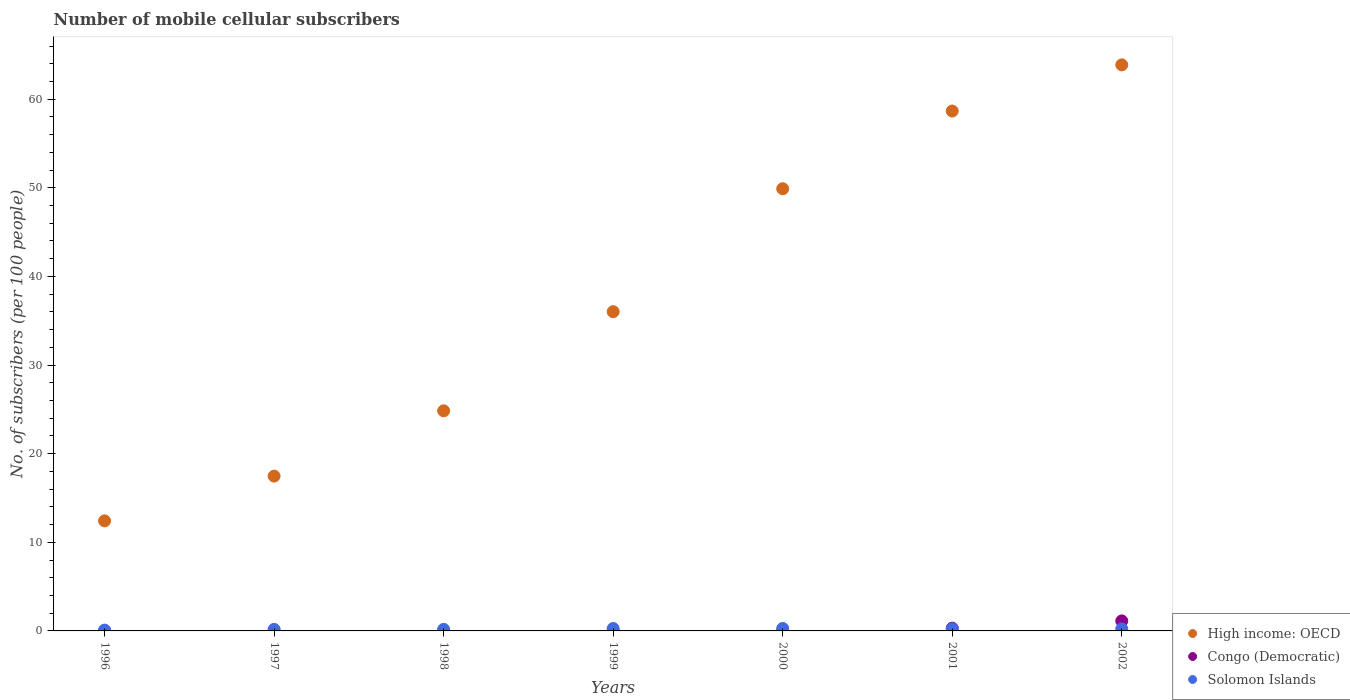How many different coloured dotlines are there?
Your answer should be very brief. 3. Is the number of dotlines equal to the number of legend labels?
Give a very brief answer. Yes. What is the number of mobile cellular subscribers in Congo (Democratic) in 2002?
Make the answer very short. 1.13. Across all years, what is the maximum number of mobile cellular subscribers in High income: OECD?
Ensure brevity in your answer.  63.87. Across all years, what is the minimum number of mobile cellular subscribers in Solomon Islands?
Your answer should be very brief. 0.09. In which year was the number of mobile cellular subscribers in Solomon Islands maximum?
Ensure brevity in your answer.  2000. What is the total number of mobile cellular subscribers in High income: OECD in the graph?
Give a very brief answer. 263.18. What is the difference between the number of mobile cellular subscribers in Solomon Islands in 1999 and that in 2002?
Provide a short and direct response. 0.04. What is the difference between the number of mobile cellular subscribers in Solomon Islands in 2000 and the number of mobile cellular subscribers in High income: OECD in 1996?
Give a very brief answer. -12.14. What is the average number of mobile cellular subscribers in High income: OECD per year?
Your answer should be very brief. 37.6. In the year 2000, what is the difference between the number of mobile cellular subscribers in High income: OECD and number of mobile cellular subscribers in Solomon Islands?
Offer a terse response. 49.62. In how many years, is the number of mobile cellular subscribers in Solomon Islands greater than 28?
Your answer should be very brief. 0. What is the ratio of the number of mobile cellular subscribers in Congo (Democratic) in 1999 to that in 2002?
Give a very brief answer. 0.02. Is the difference between the number of mobile cellular subscribers in High income: OECD in 1996 and 2001 greater than the difference between the number of mobile cellular subscribers in Solomon Islands in 1996 and 2001?
Offer a terse response. No. What is the difference between the highest and the second highest number of mobile cellular subscribers in Congo (Democratic)?
Offer a terse response. 0.82. What is the difference between the highest and the lowest number of mobile cellular subscribers in Solomon Islands?
Your answer should be very brief. 0.19. In how many years, is the number of mobile cellular subscribers in Solomon Islands greater than the average number of mobile cellular subscribers in Solomon Islands taken over all years?
Your response must be concise. 4. Does the number of mobile cellular subscribers in Solomon Islands monotonically increase over the years?
Give a very brief answer. No. Is the number of mobile cellular subscribers in High income: OECD strictly greater than the number of mobile cellular subscribers in Solomon Islands over the years?
Keep it short and to the point. Yes. Is the number of mobile cellular subscribers in Congo (Democratic) strictly less than the number of mobile cellular subscribers in Solomon Islands over the years?
Ensure brevity in your answer.  No. How many years are there in the graph?
Your answer should be very brief. 7. What is the difference between two consecutive major ticks on the Y-axis?
Your answer should be compact. 10. Does the graph contain any zero values?
Make the answer very short. No. Where does the legend appear in the graph?
Give a very brief answer. Bottom right. What is the title of the graph?
Offer a very short reply. Number of mobile cellular subscribers. What is the label or title of the Y-axis?
Offer a very short reply. No. of subscribers (per 100 people). What is the No. of subscribers (per 100 people) in High income: OECD in 1996?
Provide a succinct answer. 12.42. What is the No. of subscribers (per 100 people) of Congo (Democratic) in 1996?
Your answer should be very brief. 0.02. What is the No. of subscribers (per 100 people) of Solomon Islands in 1996?
Keep it short and to the point. 0.09. What is the No. of subscribers (per 100 people) of High income: OECD in 1997?
Your answer should be compact. 17.47. What is the No. of subscribers (per 100 people) of Congo (Democratic) in 1997?
Your response must be concise. 0.02. What is the No. of subscribers (per 100 people) in Solomon Islands in 1997?
Your answer should be very brief. 0.17. What is the No. of subscribers (per 100 people) in High income: OECD in 1998?
Ensure brevity in your answer.  24.84. What is the No. of subscribers (per 100 people) in Congo (Democratic) in 1998?
Your answer should be compact. 0.02. What is the No. of subscribers (per 100 people) in Solomon Islands in 1998?
Ensure brevity in your answer.  0.18. What is the No. of subscribers (per 100 people) of High income: OECD in 1999?
Ensure brevity in your answer.  36.03. What is the No. of subscribers (per 100 people) of Congo (Democratic) in 1999?
Your answer should be compact. 0.03. What is the No. of subscribers (per 100 people) of Solomon Islands in 1999?
Make the answer very short. 0.27. What is the No. of subscribers (per 100 people) in High income: OECD in 2000?
Keep it short and to the point. 49.9. What is the No. of subscribers (per 100 people) of Congo (Democratic) in 2000?
Provide a succinct answer. 0.03. What is the No. of subscribers (per 100 people) of Solomon Islands in 2000?
Your response must be concise. 0.28. What is the No. of subscribers (per 100 people) of High income: OECD in 2001?
Your response must be concise. 58.66. What is the No. of subscribers (per 100 people) of Congo (Democratic) in 2001?
Your answer should be compact. 0.31. What is the No. of subscribers (per 100 people) in Solomon Islands in 2001?
Your answer should be very brief. 0.23. What is the No. of subscribers (per 100 people) of High income: OECD in 2002?
Offer a terse response. 63.87. What is the No. of subscribers (per 100 people) in Congo (Democratic) in 2002?
Provide a short and direct response. 1.13. What is the No. of subscribers (per 100 people) of Solomon Islands in 2002?
Keep it short and to the point. 0.23. Across all years, what is the maximum No. of subscribers (per 100 people) of High income: OECD?
Your answer should be very brief. 63.87. Across all years, what is the maximum No. of subscribers (per 100 people) of Congo (Democratic)?
Offer a terse response. 1.13. Across all years, what is the maximum No. of subscribers (per 100 people) in Solomon Islands?
Provide a succinct answer. 0.28. Across all years, what is the minimum No. of subscribers (per 100 people) in High income: OECD?
Provide a short and direct response. 12.42. Across all years, what is the minimum No. of subscribers (per 100 people) of Congo (Democratic)?
Keep it short and to the point. 0.02. Across all years, what is the minimum No. of subscribers (per 100 people) of Solomon Islands?
Your answer should be compact. 0.09. What is the total No. of subscribers (per 100 people) of High income: OECD in the graph?
Your response must be concise. 263.18. What is the total No. of subscribers (per 100 people) in Congo (Democratic) in the graph?
Your answer should be compact. 1.56. What is the total No. of subscribers (per 100 people) in Solomon Islands in the graph?
Give a very brief answer. 1.45. What is the difference between the No. of subscribers (per 100 people) of High income: OECD in 1996 and that in 1997?
Provide a short and direct response. -5.05. What is the difference between the No. of subscribers (per 100 people) in Congo (Democratic) in 1996 and that in 1997?
Your answer should be very brief. -0. What is the difference between the No. of subscribers (per 100 people) of Solomon Islands in 1996 and that in 1997?
Give a very brief answer. -0.08. What is the difference between the No. of subscribers (per 100 people) of High income: OECD in 1996 and that in 1998?
Keep it short and to the point. -12.42. What is the difference between the No. of subscribers (per 100 people) of Congo (Democratic) in 1996 and that in 1998?
Offer a very short reply. -0.01. What is the difference between the No. of subscribers (per 100 people) of Solomon Islands in 1996 and that in 1998?
Offer a terse response. -0.09. What is the difference between the No. of subscribers (per 100 people) of High income: OECD in 1996 and that in 1999?
Offer a very short reply. -23.6. What is the difference between the No. of subscribers (per 100 people) of Congo (Democratic) in 1996 and that in 1999?
Give a very brief answer. -0.01. What is the difference between the No. of subscribers (per 100 people) of Solomon Islands in 1996 and that in 1999?
Your answer should be very brief. -0.18. What is the difference between the No. of subscribers (per 100 people) in High income: OECD in 1996 and that in 2000?
Keep it short and to the point. -37.47. What is the difference between the No. of subscribers (per 100 people) of Congo (Democratic) in 1996 and that in 2000?
Provide a succinct answer. -0.02. What is the difference between the No. of subscribers (per 100 people) in Solomon Islands in 1996 and that in 2000?
Provide a short and direct response. -0.19. What is the difference between the No. of subscribers (per 100 people) of High income: OECD in 1996 and that in 2001?
Offer a terse response. -46.24. What is the difference between the No. of subscribers (per 100 people) in Congo (Democratic) in 1996 and that in 2001?
Your answer should be very brief. -0.29. What is the difference between the No. of subscribers (per 100 people) in Solomon Islands in 1996 and that in 2001?
Give a very brief answer. -0.14. What is the difference between the No. of subscribers (per 100 people) in High income: OECD in 1996 and that in 2002?
Offer a very short reply. -51.45. What is the difference between the No. of subscribers (per 100 people) in Congo (Democratic) in 1996 and that in 2002?
Provide a succinct answer. -1.11. What is the difference between the No. of subscribers (per 100 people) in Solomon Islands in 1996 and that in 2002?
Offer a terse response. -0.14. What is the difference between the No. of subscribers (per 100 people) in High income: OECD in 1997 and that in 1998?
Keep it short and to the point. -7.37. What is the difference between the No. of subscribers (per 100 people) in Congo (Democratic) in 1997 and that in 1998?
Keep it short and to the point. -0. What is the difference between the No. of subscribers (per 100 people) of Solomon Islands in 1997 and that in 1998?
Provide a short and direct response. -0.01. What is the difference between the No. of subscribers (per 100 people) in High income: OECD in 1997 and that in 1999?
Keep it short and to the point. -18.56. What is the difference between the No. of subscribers (per 100 people) in Congo (Democratic) in 1997 and that in 1999?
Your answer should be compact. -0.01. What is the difference between the No. of subscribers (per 100 people) in Solomon Islands in 1997 and that in 1999?
Offer a very short reply. -0.1. What is the difference between the No. of subscribers (per 100 people) in High income: OECD in 1997 and that in 2000?
Provide a succinct answer. -32.43. What is the difference between the No. of subscribers (per 100 people) in Congo (Democratic) in 1997 and that in 2000?
Keep it short and to the point. -0.01. What is the difference between the No. of subscribers (per 100 people) of Solomon Islands in 1997 and that in 2000?
Give a very brief answer. -0.11. What is the difference between the No. of subscribers (per 100 people) of High income: OECD in 1997 and that in 2001?
Offer a very short reply. -41.19. What is the difference between the No. of subscribers (per 100 people) of Congo (Democratic) in 1997 and that in 2001?
Provide a succinct answer. -0.29. What is the difference between the No. of subscribers (per 100 people) of Solomon Islands in 1997 and that in 2001?
Provide a short and direct response. -0.06. What is the difference between the No. of subscribers (per 100 people) of High income: OECD in 1997 and that in 2002?
Offer a very short reply. -46.4. What is the difference between the No. of subscribers (per 100 people) of Congo (Democratic) in 1997 and that in 2002?
Make the answer very short. -1.11. What is the difference between the No. of subscribers (per 100 people) of Solomon Islands in 1997 and that in 2002?
Provide a short and direct response. -0.06. What is the difference between the No. of subscribers (per 100 people) of High income: OECD in 1998 and that in 1999?
Offer a very short reply. -11.19. What is the difference between the No. of subscribers (per 100 people) of Congo (Democratic) in 1998 and that in 1999?
Your answer should be very brief. -0. What is the difference between the No. of subscribers (per 100 people) of Solomon Islands in 1998 and that in 1999?
Your answer should be very brief. -0.09. What is the difference between the No. of subscribers (per 100 people) in High income: OECD in 1998 and that in 2000?
Keep it short and to the point. -25.06. What is the difference between the No. of subscribers (per 100 people) of Congo (Democratic) in 1998 and that in 2000?
Make the answer very short. -0.01. What is the difference between the No. of subscribers (per 100 people) of Solomon Islands in 1998 and that in 2000?
Your response must be concise. -0.1. What is the difference between the No. of subscribers (per 100 people) of High income: OECD in 1998 and that in 2001?
Provide a short and direct response. -33.83. What is the difference between the No. of subscribers (per 100 people) in Congo (Democratic) in 1998 and that in 2001?
Provide a succinct answer. -0.29. What is the difference between the No. of subscribers (per 100 people) of Solomon Islands in 1998 and that in 2001?
Ensure brevity in your answer.  -0.05. What is the difference between the No. of subscribers (per 100 people) of High income: OECD in 1998 and that in 2002?
Your answer should be compact. -39.04. What is the difference between the No. of subscribers (per 100 people) of Congo (Democratic) in 1998 and that in 2002?
Make the answer very short. -1.11. What is the difference between the No. of subscribers (per 100 people) of Solomon Islands in 1998 and that in 2002?
Your answer should be compact. -0.05. What is the difference between the No. of subscribers (per 100 people) in High income: OECD in 1999 and that in 2000?
Your answer should be very brief. -13.87. What is the difference between the No. of subscribers (per 100 people) in Congo (Democratic) in 1999 and that in 2000?
Provide a short and direct response. -0.01. What is the difference between the No. of subscribers (per 100 people) in Solomon Islands in 1999 and that in 2000?
Your answer should be very brief. -0.01. What is the difference between the No. of subscribers (per 100 people) in High income: OECD in 1999 and that in 2001?
Provide a succinct answer. -22.64. What is the difference between the No. of subscribers (per 100 people) in Congo (Democratic) in 1999 and that in 2001?
Offer a very short reply. -0.29. What is the difference between the No. of subscribers (per 100 people) of Solomon Islands in 1999 and that in 2001?
Ensure brevity in your answer.  0.04. What is the difference between the No. of subscribers (per 100 people) of High income: OECD in 1999 and that in 2002?
Offer a terse response. -27.85. What is the difference between the No. of subscribers (per 100 people) of Congo (Democratic) in 1999 and that in 2002?
Ensure brevity in your answer.  -1.1. What is the difference between the No. of subscribers (per 100 people) in Solomon Islands in 1999 and that in 2002?
Your answer should be very brief. 0.04. What is the difference between the No. of subscribers (per 100 people) of High income: OECD in 2000 and that in 2001?
Provide a short and direct response. -8.77. What is the difference between the No. of subscribers (per 100 people) in Congo (Democratic) in 2000 and that in 2001?
Make the answer very short. -0.28. What is the difference between the No. of subscribers (per 100 people) in Solomon Islands in 2000 and that in 2001?
Offer a very short reply. 0.05. What is the difference between the No. of subscribers (per 100 people) of High income: OECD in 2000 and that in 2002?
Your response must be concise. -13.98. What is the difference between the No. of subscribers (per 100 people) of Congo (Democratic) in 2000 and that in 2002?
Your answer should be compact. -1.1. What is the difference between the No. of subscribers (per 100 people) of Solomon Islands in 2000 and that in 2002?
Your response must be concise. 0.05. What is the difference between the No. of subscribers (per 100 people) in High income: OECD in 2001 and that in 2002?
Give a very brief answer. -5.21. What is the difference between the No. of subscribers (per 100 people) of Congo (Democratic) in 2001 and that in 2002?
Your answer should be very brief. -0.82. What is the difference between the No. of subscribers (per 100 people) in Solomon Islands in 2001 and that in 2002?
Your answer should be very brief. -0. What is the difference between the No. of subscribers (per 100 people) in High income: OECD in 1996 and the No. of subscribers (per 100 people) in Congo (Democratic) in 1997?
Make the answer very short. 12.4. What is the difference between the No. of subscribers (per 100 people) of High income: OECD in 1996 and the No. of subscribers (per 100 people) of Solomon Islands in 1997?
Your response must be concise. 12.25. What is the difference between the No. of subscribers (per 100 people) in Congo (Democratic) in 1996 and the No. of subscribers (per 100 people) in Solomon Islands in 1997?
Ensure brevity in your answer.  -0.16. What is the difference between the No. of subscribers (per 100 people) in High income: OECD in 1996 and the No. of subscribers (per 100 people) in Congo (Democratic) in 1998?
Make the answer very short. 12.4. What is the difference between the No. of subscribers (per 100 people) in High income: OECD in 1996 and the No. of subscribers (per 100 people) in Solomon Islands in 1998?
Make the answer very short. 12.24. What is the difference between the No. of subscribers (per 100 people) in Congo (Democratic) in 1996 and the No. of subscribers (per 100 people) in Solomon Islands in 1998?
Your answer should be compact. -0.16. What is the difference between the No. of subscribers (per 100 people) in High income: OECD in 1996 and the No. of subscribers (per 100 people) in Congo (Democratic) in 1999?
Offer a very short reply. 12.4. What is the difference between the No. of subscribers (per 100 people) in High income: OECD in 1996 and the No. of subscribers (per 100 people) in Solomon Islands in 1999?
Provide a short and direct response. 12.15. What is the difference between the No. of subscribers (per 100 people) in Congo (Democratic) in 1996 and the No. of subscribers (per 100 people) in Solomon Islands in 1999?
Your response must be concise. -0.26. What is the difference between the No. of subscribers (per 100 people) of High income: OECD in 1996 and the No. of subscribers (per 100 people) of Congo (Democratic) in 2000?
Your response must be concise. 12.39. What is the difference between the No. of subscribers (per 100 people) in High income: OECD in 1996 and the No. of subscribers (per 100 people) in Solomon Islands in 2000?
Offer a very short reply. 12.14. What is the difference between the No. of subscribers (per 100 people) in Congo (Democratic) in 1996 and the No. of subscribers (per 100 people) in Solomon Islands in 2000?
Your response must be concise. -0.26. What is the difference between the No. of subscribers (per 100 people) of High income: OECD in 1996 and the No. of subscribers (per 100 people) of Congo (Democratic) in 2001?
Your answer should be compact. 12.11. What is the difference between the No. of subscribers (per 100 people) of High income: OECD in 1996 and the No. of subscribers (per 100 people) of Solomon Islands in 2001?
Keep it short and to the point. 12.19. What is the difference between the No. of subscribers (per 100 people) of Congo (Democratic) in 1996 and the No. of subscribers (per 100 people) of Solomon Islands in 2001?
Offer a terse response. -0.21. What is the difference between the No. of subscribers (per 100 people) of High income: OECD in 1996 and the No. of subscribers (per 100 people) of Congo (Democratic) in 2002?
Your answer should be very brief. 11.29. What is the difference between the No. of subscribers (per 100 people) of High income: OECD in 1996 and the No. of subscribers (per 100 people) of Solomon Islands in 2002?
Give a very brief answer. 12.19. What is the difference between the No. of subscribers (per 100 people) in Congo (Democratic) in 1996 and the No. of subscribers (per 100 people) in Solomon Islands in 2002?
Make the answer very short. -0.21. What is the difference between the No. of subscribers (per 100 people) in High income: OECD in 1997 and the No. of subscribers (per 100 people) in Congo (Democratic) in 1998?
Your answer should be very brief. 17.45. What is the difference between the No. of subscribers (per 100 people) in High income: OECD in 1997 and the No. of subscribers (per 100 people) in Solomon Islands in 1998?
Provide a succinct answer. 17.29. What is the difference between the No. of subscribers (per 100 people) in Congo (Democratic) in 1997 and the No. of subscribers (per 100 people) in Solomon Islands in 1998?
Your answer should be very brief. -0.16. What is the difference between the No. of subscribers (per 100 people) of High income: OECD in 1997 and the No. of subscribers (per 100 people) of Congo (Democratic) in 1999?
Offer a very short reply. 17.44. What is the difference between the No. of subscribers (per 100 people) of High income: OECD in 1997 and the No. of subscribers (per 100 people) of Solomon Islands in 1999?
Make the answer very short. 17.2. What is the difference between the No. of subscribers (per 100 people) of Congo (Democratic) in 1997 and the No. of subscribers (per 100 people) of Solomon Islands in 1999?
Keep it short and to the point. -0.25. What is the difference between the No. of subscribers (per 100 people) of High income: OECD in 1997 and the No. of subscribers (per 100 people) of Congo (Democratic) in 2000?
Provide a succinct answer. 17.44. What is the difference between the No. of subscribers (per 100 people) of High income: OECD in 1997 and the No. of subscribers (per 100 people) of Solomon Islands in 2000?
Your answer should be very brief. 17.19. What is the difference between the No. of subscribers (per 100 people) in Congo (Democratic) in 1997 and the No. of subscribers (per 100 people) in Solomon Islands in 2000?
Keep it short and to the point. -0.26. What is the difference between the No. of subscribers (per 100 people) of High income: OECD in 1997 and the No. of subscribers (per 100 people) of Congo (Democratic) in 2001?
Make the answer very short. 17.16. What is the difference between the No. of subscribers (per 100 people) of High income: OECD in 1997 and the No. of subscribers (per 100 people) of Solomon Islands in 2001?
Offer a terse response. 17.24. What is the difference between the No. of subscribers (per 100 people) of Congo (Democratic) in 1997 and the No. of subscribers (per 100 people) of Solomon Islands in 2001?
Ensure brevity in your answer.  -0.21. What is the difference between the No. of subscribers (per 100 people) in High income: OECD in 1997 and the No. of subscribers (per 100 people) in Congo (Democratic) in 2002?
Provide a short and direct response. 16.34. What is the difference between the No. of subscribers (per 100 people) in High income: OECD in 1997 and the No. of subscribers (per 100 people) in Solomon Islands in 2002?
Your response must be concise. 17.24. What is the difference between the No. of subscribers (per 100 people) in Congo (Democratic) in 1997 and the No. of subscribers (per 100 people) in Solomon Islands in 2002?
Offer a terse response. -0.21. What is the difference between the No. of subscribers (per 100 people) in High income: OECD in 1998 and the No. of subscribers (per 100 people) in Congo (Democratic) in 1999?
Ensure brevity in your answer.  24.81. What is the difference between the No. of subscribers (per 100 people) of High income: OECD in 1998 and the No. of subscribers (per 100 people) of Solomon Islands in 1999?
Make the answer very short. 24.56. What is the difference between the No. of subscribers (per 100 people) of Congo (Democratic) in 1998 and the No. of subscribers (per 100 people) of Solomon Islands in 1999?
Ensure brevity in your answer.  -0.25. What is the difference between the No. of subscribers (per 100 people) of High income: OECD in 1998 and the No. of subscribers (per 100 people) of Congo (Democratic) in 2000?
Your answer should be very brief. 24.8. What is the difference between the No. of subscribers (per 100 people) in High income: OECD in 1998 and the No. of subscribers (per 100 people) in Solomon Islands in 2000?
Your response must be concise. 24.56. What is the difference between the No. of subscribers (per 100 people) in Congo (Democratic) in 1998 and the No. of subscribers (per 100 people) in Solomon Islands in 2000?
Provide a short and direct response. -0.26. What is the difference between the No. of subscribers (per 100 people) in High income: OECD in 1998 and the No. of subscribers (per 100 people) in Congo (Democratic) in 2001?
Give a very brief answer. 24.53. What is the difference between the No. of subscribers (per 100 people) in High income: OECD in 1998 and the No. of subscribers (per 100 people) in Solomon Islands in 2001?
Make the answer very short. 24.61. What is the difference between the No. of subscribers (per 100 people) of Congo (Democratic) in 1998 and the No. of subscribers (per 100 people) of Solomon Islands in 2001?
Make the answer very short. -0.21. What is the difference between the No. of subscribers (per 100 people) of High income: OECD in 1998 and the No. of subscribers (per 100 people) of Congo (Democratic) in 2002?
Offer a terse response. 23.71. What is the difference between the No. of subscribers (per 100 people) of High income: OECD in 1998 and the No. of subscribers (per 100 people) of Solomon Islands in 2002?
Your answer should be compact. 24.61. What is the difference between the No. of subscribers (per 100 people) of Congo (Democratic) in 1998 and the No. of subscribers (per 100 people) of Solomon Islands in 2002?
Provide a short and direct response. -0.21. What is the difference between the No. of subscribers (per 100 people) in High income: OECD in 1999 and the No. of subscribers (per 100 people) in Congo (Democratic) in 2000?
Your answer should be very brief. 35.99. What is the difference between the No. of subscribers (per 100 people) in High income: OECD in 1999 and the No. of subscribers (per 100 people) in Solomon Islands in 2000?
Your answer should be very brief. 35.75. What is the difference between the No. of subscribers (per 100 people) of Congo (Democratic) in 1999 and the No. of subscribers (per 100 people) of Solomon Islands in 2000?
Ensure brevity in your answer.  -0.25. What is the difference between the No. of subscribers (per 100 people) in High income: OECD in 1999 and the No. of subscribers (per 100 people) in Congo (Democratic) in 2001?
Ensure brevity in your answer.  35.71. What is the difference between the No. of subscribers (per 100 people) of High income: OECD in 1999 and the No. of subscribers (per 100 people) of Solomon Islands in 2001?
Give a very brief answer. 35.8. What is the difference between the No. of subscribers (per 100 people) in Congo (Democratic) in 1999 and the No. of subscribers (per 100 people) in Solomon Islands in 2001?
Ensure brevity in your answer.  -0.2. What is the difference between the No. of subscribers (per 100 people) in High income: OECD in 1999 and the No. of subscribers (per 100 people) in Congo (Democratic) in 2002?
Offer a terse response. 34.89. What is the difference between the No. of subscribers (per 100 people) in High income: OECD in 1999 and the No. of subscribers (per 100 people) in Solomon Islands in 2002?
Provide a succinct answer. 35.8. What is the difference between the No. of subscribers (per 100 people) in Congo (Democratic) in 1999 and the No. of subscribers (per 100 people) in Solomon Islands in 2002?
Your answer should be compact. -0.2. What is the difference between the No. of subscribers (per 100 people) in High income: OECD in 2000 and the No. of subscribers (per 100 people) in Congo (Democratic) in 2001?
Offer a terse response. 49.58. What is the difference between the No. of subscribers (per 100 people) in High income: OECD in 2000 and the No. of subscribers (per 100 people) in Solomon Islands in 2001?
Offer a terse response. 49.67. What is the difference between the No. of subscribers (per 100 people) of Congo (Democratic) in 2000 and the No. of subscribers (per 100 people) of Solomon Islands in 2001?
Provide a short and direct response. -0.2. What is the difference between the No. of subscribers (per 100 people) in High income: OECD in 2000 and the No. of subscribers (per 100 people) in Congo (Democratic) in 2002?
Offer a terse response. 48.77. What is the difference between the No. of subscribers (per 100 people) in High income: OECD in 2000 and the No. of subscribers (per 100 people) in Solomon Islands in 2002?
Provide a short and direct response. 49.67. What is the difference between the No. of subscribers (per 100 people) of Congo (Democratic) in 2000 and the No. of subscribers (per 100 people) of Solomon Islands in 2002?
Offer a very short reply. -0.2. What is the difference between the No. of subscribers (per 100 people) of High income: OECD in 2001 and the No. of subscribers (per 100 people) of Congo (Democratic) in 2002?
Provide a short and direct response. 57.53. What is the difference between the No. of subscribers (per 100 people) in High income: OECD in 2001 and the No. of subscribers (per 100 people) in Solomon Islands in 2002?
Your answer should be compact. 58.43. What is the difference between the No. of subscribers (per 100 people) of Congo (Democratic) in 2001 and the No. of subscribers (per 100 people) of Solomon Islands in 2002?
Your answer should be very brief. 0.08. What is the average No. of subscribers (per 100 people) in High income: OECD per year?
Keep it short and to the point. 37.6. What is the average No. of subscribers (per 100 people) of Congo (Democratic) per year?
Your answer should be very brief. 0.22. What is the average No. of subscribers (per 100 people) of Solomon Islands per year?
Provide a succinct answer. 0.21. In the year 1996, what is the difference between the No. of subscribers (per 100 people) of High income: OECD and No. of subscribers (per 100 people) of Congo (Democratic)?
Offer a terse response. 12.4. In the year 1996, what is the difference between the No. of subscribers (per 100 people) of High income: OECD and No. of subscribers (per 100 people) of Solomon Islands?
Keep it short and to the point. 12.33. In the year 1996, what is the difference between the No. of subscribers (per 100 people) of Congo (Democratic) and No. of subscribers (per 100 people) of Solomon Islands?
Give a very brief answer. -0.07. In the year 1997, what is the difference between the No. of subscribers (per 100 people) of High income: OECD and No. of subscribers (per 100 people) of Congo (Democratic)?
Offer a terse response. 17.45. In the year 1997, what is the difference between the No. of subscribers (per 100 people) of High income: OECD and No. of subscribers (per 100 people) of Solomon Islands?
Make the answer very short. 17.3. In the year 1997, what is the difference between the No. of subscribers (per 100 people) in Congo (Democratic) and No. of subscribers (per 100 people) in Solomon Islands?
Give a very brief answer. -0.15. In the year 1998, what is the difference between the No. of subscribers (per 100 people) in High income: OECD and No. of subscribers (per 100 people) in Congo (Democratic)?
Keep it short and to the point. 24.81. In the year 1998, what is the difference between the No. of subscribers (per 100 people) in High income: OECD and No. of subscribers (per 100 people) in Solomon Islands?
Your answer should be compact. 24.66. In the year 1998, what is the difference between the No. of subscribers (per 100 people) of Congo (Democratic) and No. of subscribers (per 100 people) of Solomon Islands?
Your response must be concise. -0.16. In the year 1999, what is the difference between the No. of subscribers (per 100 people) in High income: OECD and No. of subscribers (per 100 people) in Congo (Democratic)?
Ensure brevity in your answer.  36. In the year 1999, what is the difference between the No. of subscribers (per 100 people) in High income: OECD and No. of subscribers (per 100 people) in Solomon Islands?
Your answer should be compact. 35.75. In the year 1999, what is the difference between the No. of subscribers (per 100 people) of Congo (Democratic) and No. of subscribers (per 100 people) of Solomon Islands?
Your answer should be very brief. -0.25. In the year 2000, what is the difference between the No. of subscribers (per 100 people) of High income: OECD and No. of subscribers (per 100 people) of Congo (Democratic)?
Your response must be concise. 49.86. In the year 2000, what is the difference between the No. of subscribers (per 100 people) of High income: OECD and No. of subscribers (per 100 people) of Solomon Islands?
Make the answer very short. 49.62. In the year 2000, what is the difference between the No. of subscribers (per 100 people) in Congo (Democratic) and No. of subscribers (per 100 people) in Solomon Islands?
Provide a short and direct response. -0.25. In the year 2001, what is the difference between the No. of subscribers (per 100 people) of High income: OECD and No. of subscribers (per 100 people) of Congo (Democratic)?
Make the answer very short. 58.35. In the year 2001, what is the difference between the No. of subscribers (per 100 people) of High income: OECD and No. of subscribers (per 100 people) of Solomon Islands?
Your answer should be very brief. 58.43. In the year 2001, what is the difference between the No. of subscribers (per 100 people) of Congo (Democratic) and No. of subscribers (per 100 people) of Solomon Islands?
Give a very brief answer. 0.08. In the year 2002, what is the difference between the No. of subscribers (per 100 people) of High income: OECD and No. of subscribers (per 100 people) of Congo (Democratic)?
Offer a very short reply. 62.74. In the year 2002, what is the difference between the No. of subscribers (per 100 people) in High income: OECD and No. of subscribers (per 100 people) in Solomon Islands?
Offer a terse response. 63.64. In the year 2002, what is the difference between the No. of subscribers (per 100 people) of Congo (Democratic) and No. of subscribers (per 100 people) of Solomon Islands?
Offer a terse response. 0.9. What is the ratio of the No. of subscribers (per 100 people) in High income: OECD in 1996 to that in 1997?
Make the answer very short. 0.71. What is the ratio of the No. of subscribers (per 100 people) of Congo (Democratic) in 1996 to that in 1997?
Your answer should be very brief. 0.83. What is the ratio of the No. of subscribers (per 100 people) of Solomon Islands in 1996 to that in 1997?
Your answer should be very brief. 0.53. What is the ratio of the No. of subscribers (per 100 people) of High income: OECD in 1996 to that in 1998?
Offer a very short reply. 0.5. What is the ratio of the No. of subscribers (per 100 people) in Congo (Democratic) in 1996 to that in 1998?
Make the answer very short. 0.75. What is the ratio of the No. of subscribers (per 100 people) of Solomon Islands in 1996 to that in 1998?
Your answer should be compact. 0.51. What is the ratio of the No. of subscribers (per 100 people) of High income: OECD in 1996 to that in 1999?
Keep it short and to the point. 0.34. What is the ratio of the No. of subscribers (per 100 people) of Congo (Democratic) in 1996 to that in 1999?
Your answer should be very brief. 0.64. What is the ratio of the No. of subscribers (per 100 people) of Solomon Islands in 1996 to that in 1999?
Provide a succinct answer. 0.33. What is the ratio of the No. of subscribers (per 100 people) of High income: OECD in 1996 to that in 2000?
Your answer should be compact. 0.25. What is the ratio of the No. of subscribers (per 100 people) in Congo (Democratic) in 1996 to that in 2000?
Your response must be concise. 0.52. What is the ratio of the No. of subscribers (per 100 people) of Solomon Islands in 1996 to that in 2000?
Make the answer very short. 0.33. What is the ratio of the No. of subscribers (per 100 people) in High income: OECD in 1996 to that in 2001?
Offer a very short reply. 0.21. What is the ratio of the No. of subscribers (per 100 people) of Congo (Democratic) in 1996 to that in 2001?
Your answer should be very brief. 0.05. What is the ratio of the No. of subscribers (per 100 people) in Solomon Islands in 1996 to that in 2001?
Ensure brevity in your answer.  0.4. What is the ratio of the No. of subscribers (per 100 people) of High income: OECD in 1996 to that in 2002?
Offer a very short reply. 0.19. What is the ratio of the No. of subscribers (per 100 people) of Congo (Democratic) in 1996 to that in 2002?
Offer a very short reply. 0.01. What is the ratio of the No. of subscribers (per 100 people) in Solomon Islands in 1996 to that in 2002?
Make the answer very short. 0.4. What is the ratio of the No. of subscribers (per 100 people) in High income: OECD in 1997 to that in 1998?
Offer a terse response. 0.7. What is the ratio of the No. of subscribers (per 100 people) of Congo (Democratic) in 1997 to that in 1998?
Provide a short and direct response. 0.91. What is the ratio of the No. of subscribers (per 100 people) in Solomon Islands in 1997 to that in 1998?
Your answer should be compact. 0.96. What is the ratio of the No. of subscribers (per 100 people) of High income: OECD in 1997 to that in 1999?
Your answer should be very brief. 0.48. What is the ratio of the No. of subscribers (per 100 people) in Congo (Democratic) in 1997 to that in 1999?
Your answer should be compact. 0.77. What is the ratio of the No. of subscribers (per 100 people) of Solomon Islands in 1997 to that in 1999?
Make the answer very short. 0.64. What is the ratio of the No. of subscribers (per 100 people) in High income: OECD in 1997 to that in 2000?
Make the answer very short. 0.35. What is the ratio of the No. of subscribers (per 100 people) in Congo (Democratic) in 1997 to that in 2000?
Make the answer very short. 0.63. What is the ratio of the No. of subscribers (per 100 people) in Solomon Islands in 1997 to that in 2000?
Your response must be concise. 0.62. What is the ratio of the No. of subscribers (per 100 people) in High income: OECD in 1997 to that in 2001?
Provide a succinct answer. 0.3. What is the ratio of the No. of subscribers (per 100 people) in Congo (Democratic) in 1997 to that in 2001?
Offer a terse response. 0.06. What is the ratio of the No. of subscribers (per 100 people) in Solomon Islands in 1997 to that in 2001?
Offer a terse response. 0.76. What is the ratio of the No. of subscribers (per 100 people) in High income: OECD in 1997 to that in 2002?
Offer a very short reply. 0.27. What is the ratio of the No. of subscribers (per 100 people) in Congo (Democratic) in 1997 to that in 2002?
Your answer should be compact. 0.02. What is the ratio of the No. of subscribers (per 100 people) of Solomon Islands in 1997 to that in 2002?
Make the answer very short. 0.75. What is the ratio of the No. of subscribers (per 100 people) of High income: OECD in 1998 to that in 1999?
Offer a very short reply. 0.69. What is the ratio of the No. of subscribers (per 100 people) of Congo (Democratic) in 1998 to that in 1999?
Keep it short and to the point. 0.85. What is the ratio of the No. of subscribers (per 100 people) in Solomon Islands in 1998 to that in 1999?
Your response must be concise. 0.66. What is the ratio of the No. of subscribers (per 100 people) in High income: OECD in 1998 to that in 2000?
Keep it short and to the point. 0.5. What is the ratio of the No. of subscribers (per 100 people) of Congo (Democratic) in 1998 to that in 2000?
Keep it short and to the point. 0.7. What is the ratio of the No. of subscribers (per 100 people) of Solomon Islands in 1998 to that in 2000?
Your answer should be very brief. 0.64. What is the ratio of the No. of subscribers (per 100 people) of High income: OECD in 1998 to that in 2001?
Give a very brief answer. 0.42. What is the ratio of the No. of subscribers (per 100 people) of Congo (Democratic) in 1998 to that in 2001?
Give a very brief answer. 0.07. What is the ratio of the No. of subscribers (per 100 people) in Solomon Islands in 1998 to that in 2001?
Keep it short and to the point. 0.79. What is the ratio of the No. of subscribers (per 100 people) of High income: OECD in 1998 to that in 2002?
Offer a very short reply. 0.39. What is the ratio of the No. of subscribers (per 100 people) in Congo (Democratic) in 1998 to that in 2002?
Offer a terse response. 0.02. What is the ratio of the No. of subscribers (per 100 people) in Solomon Islands in 1998 to that in 2002?
Your response must be concise. 0.78. What is the ratio of the No. of subscribers (per 100 people) of High income: OECD in 1999 to that in 2000?
Your answer should be compact. 0.72. What is the ratio of the No. of subscribers (per 100 people) in Congo (Democratic) in 1999 to that in 2000?
Your answer should be compact. 0.82. What is the ratio of the No. of subscribers (per 100 people) of Solomon Islands in 1999 to that in 2000?
Offer a terse response. 0.98. What is the ratio of the No. of subscribers (per 100 people) in High income: OECD in 1999 to that in 2001?
Your response must be concise. 0.61. What is the ratio of the No. of subscribers (per 100 people) in Congo (Democratic) in 1999 to that in 2001?
Keep it short and to the point. 0.08. What is the ratio of the No. of subscribers (per 100 people) in Solomon Islands in 1999 to that in 2001?
Your answer should be compact. 1.19. What is the ratio of the No. of subscribers (per 100 people) in High income: OECD in 1999 to that in 2002?
Your answer should be very brief. 0.56. What is the ratio of the No. of subscribers (per 100 people) in Congo (Democratic) in 1999 to that in 2002?
Provide a short and direct response. 0.02. What is the ratio of the No. of subscribers (per 100 people) in Solomon Islands in 1999 to that in 2002?
Your answer should be very brief. 1.19. What is the ratio of the No. of subscribers (per 100 people) of High income: OECD in 2000 to that in 2001?
Your answer should be very brief. 0.85. What is the ratio of the No. of subscribers (per 100 people) in Congo (Democratic) in 2000 to that in 2001?
Ensure brevity in your answer.  0.1. What is the ratio of the No. of subscribers (per 100 people) of Solomon Islands in 2000 to that in 2001?
Offer a very short reply. 1.22. What is the ratio of the No. of subscribers (per 100 people) in High income: OECD in 2000 to that in 2002?
Provide a succinct answer. 0.78. What is the ratio of the No. of subscribers (per 100 people) in Congo (Democratic) in 2000 to that in 2002?
Give a very brief answer. 0.03. What is the ratio of the No. of subscribers (per 100 people) in Solomon Islands in 2000 to that in 2002?
Offer a terse response. 1.22. What is the ratio of the No. of subscribers (per 100 people) of High income: OECD in 2001 to that in 2002?
Provide a succinct answer. 0.92. What is the ratio of the No. of subscribers (per 100 people) in Congo (Democratic) in 2001 to that in 2002?
Keep it short and to the point. 0.28. What is the difference between the highest and the second highest No. of subscribers (per 100 people) in High income: OECD?
Provide a succinct answer. 5.21. What is the difference between the highest and the second highest No. of subscribers (per 100 people) in Congo (Democratic)?
Offer a very short reply. 0.82. What is the difference between the highest and the second highest No. of subscribers (per 100 people) of Solomon Islands?
Your response must be concise. 0.01. What is the difference between the highest and the lowest No. of subscribers (per 100 people) in High income: OECD?
Provide a short and direct response. 51.45. What is the difference between the highest and the lowest No. of subscribers (per 100 people) of Congo (Democratic)?
Make the answer very short. 1.11. What is the difference between the highest and the lowest No. of subscribers (per 100 people) of Solomon Islands?
Your response must be concise. 0.19. 